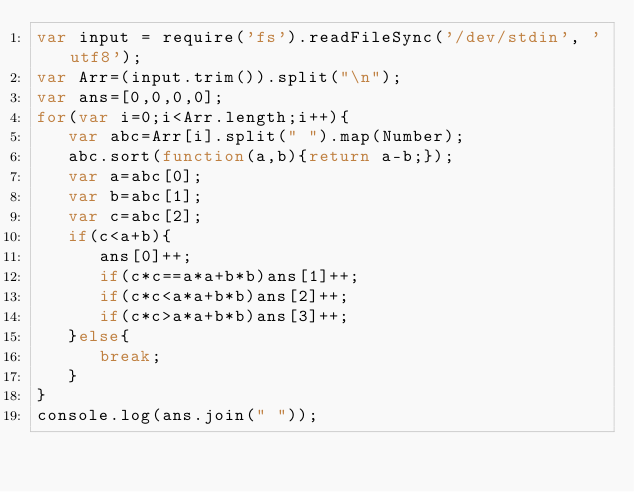Convert code to text. <code><loc_0><loc_0><loc_500><loc_500><_JavaScript_>var input = require('fs').readFileSync('/dev/stdin', 'utf8');
var Arr=(input.trim()).split("\n");
var ans=[0,0,0,0];
for(var i=0;i<Arr.length;i++){
   var abc=Arr[i].split(" ").map(Number);
   abc.sort(function(a,b){return a-b;});
   var a=abc[0];
   var b=abc[1];
   var c=abc[2];
   if(c<a+b){
      ans[0]++;
      if(c*c==a*a+b*b)ans[1]++;
      if(c*c<a*a+b*b)ans[2]++;
      if(c*c>a*a+b*b)ans[3]++;
   }else{
      break;
   }
}
console.log(ans.join(" "));</code> 